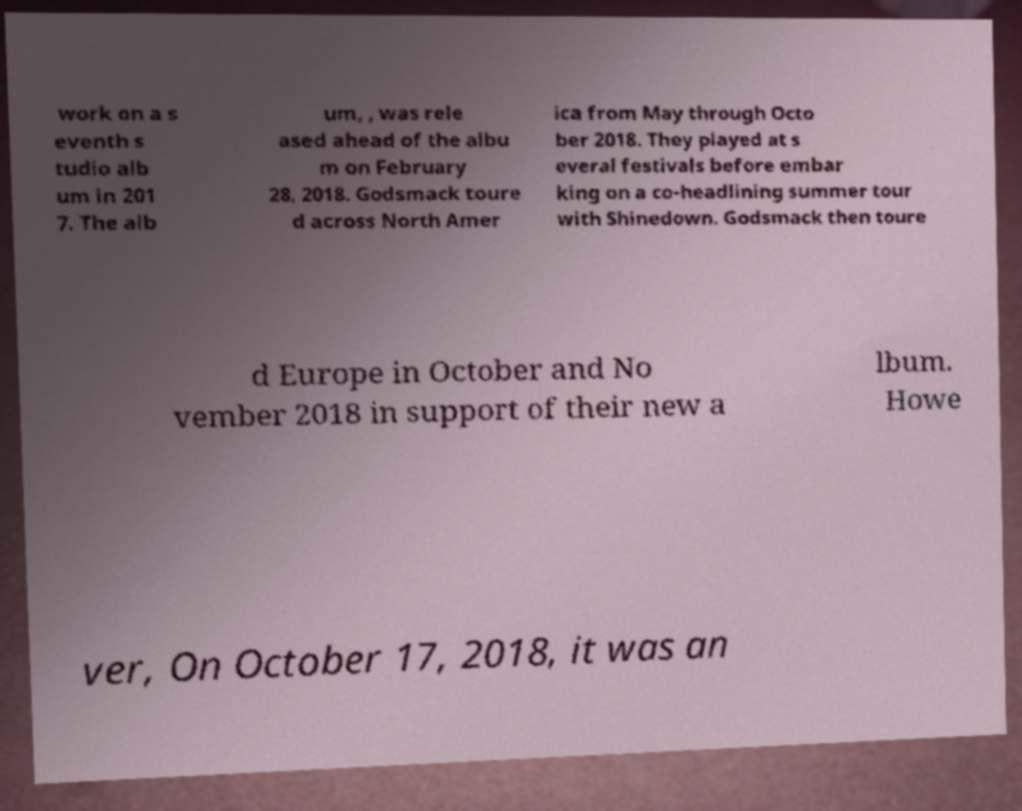Please identify and transcribe the text found in this image. work on a s eventh s tudio alb um in 201 7. The alb um, , was rele ased ahead of the albu m on February 28, 2018. Godsmack toure d across North Amer ica from May through Octo ber 2018. They played at s everal festivals before embar king on a co-headlining summer tour with Shinedown. Godsmack then toure d Europe in October and No vember 2018 in support of their new a lbum. Howe ver, On October 17, 2018, it was an 